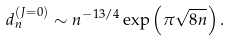Convert formula to latex. <formula><loc_0><loc_0><loc_500><loc_500>d ^ { ( J = 0 ) } _ { n } \sim n ^ { - 1 3 / 4 } \exp \left ( \pi \sqrt { 8 n } \right ) .</formula> 